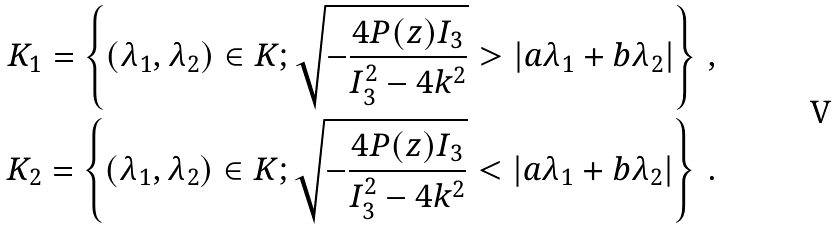<formula> <loc_0><loc_0><loc_500><loc_500>K _ { 1 } = \left \{ ( \lambda _ { 1 } , \lambda _ { 2 } ) \in K ; \sqrt { - \frac { 4 P ( z ) I _ { 3 } } { I _ { 3 } ^ { 2 } - 4 k ^ { 2 } } } > | a \lambda _ { 1 } + b \lambda _ { 2 } | \right \} \, , \\ K _ { 2 } = \left \{ ( \lambda _ { 1 } , \lambda _ { 2 } ) \in K ; \sqrt { - \frac { 4 P ( z ) I _ { 3 } } { I _ { 3 } ^ { 2 } - 4 k ^ { 2 } } } < | a \lambda _ { 1 } + b \lambda _ { 2 } | \right \} \, .</formula> 